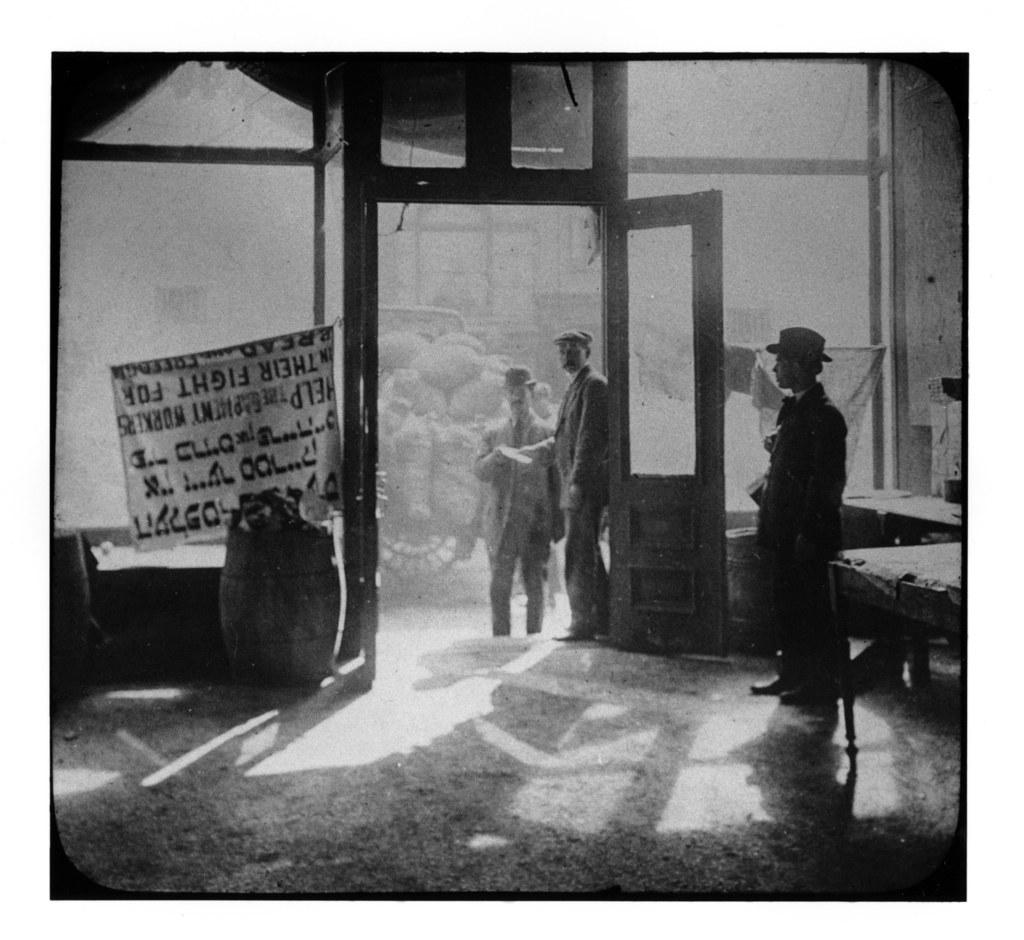What type of picture is in the image? The image contains a black and white picture. What can be seen in the picture? There are persons standing in the picture. What architectural feature is visible in the picture? There is a door visible in the picture. What type of furniture is in the picture? There are tables in the picture. What additional object is present in the picture? There is a banner in the picture. What type of fowl can be seen sitting on the tables in the image? There are no fowl visible in the image; the tables are empty. What material is the hat made of that is worn by the person in the image? There is no hat present in the image, so it cannot be determined what material it would be made of. 